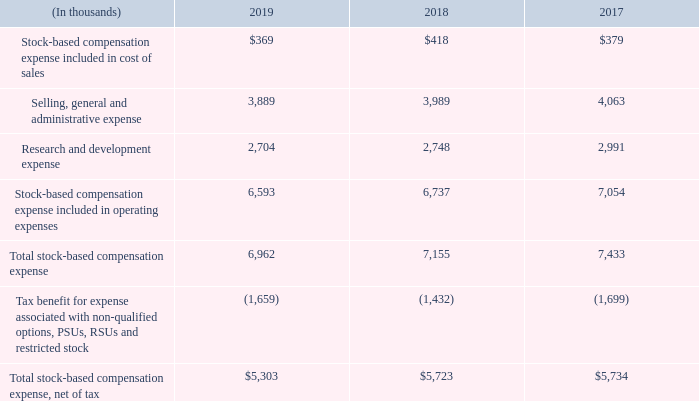Note 4 – Stock-Based Compensation
Stock Incentive Program Descriptions
In January 2006, the Board of Directors adopted the ADTRAN, Inc. 2006 Employee Stock Incentive Plan (the “2006 Plan”), which authorized 13.0 million shares of common stock for issuance to certain employees and officers through incentive stock options and non-qualified stock options, stock appreciation rights, RSUs and restricted stock. The 2006 Plan was adopted by stockholder approval at our annual meeting of stockholders held in May 2006. Options granted under the 2006 Plan typically become exercisable beginning after one year of continued employment, normally pursuant to a four-year vesting schedule beginning on the first anniversary of the grant date and had a ten-year contractual term. The 2006 Plan was replaced in May 2015 by the ADTRAN, Inc. 2015 Employee Stock Incentive Plan (the “2015 Plan”). Expiration dates of options outstanding as of December 31, 2019 under the 2006 Plan range from 2020 to 2024.
In January 2015, the Board of Directors adopted the 2015 Plan, which authorized 7.7 million shares of common stock for issuance to certain employees and officers through incentive stock options and non-qualified stock options, stock appreciation rights, PSUs, RSUs and restricted stock. The 2015 Plan was adopted by stockholder approval at our annual meeting of stockholders held in May 2015. PSUs, RSUs and restricted stock granted under the 2015 Plan reduce the shares authorized for issuance under the 2015 Plan by 2.5 shares of common stock for each share underlying the award. Options granted under the 2015 Plan typically become exercisable beginning after one year of continued employment, normally pursuant to a four-year vesting schedule beginning on the first anniversary of the grant date and have a ten-year contractual term. Expiration dates of options outstanding as of December 31, 2019 under the 2015 Plan range from 2025 to 2026.
Our stockholders approved the 2010 Directors Stock Plan (the “2010 Directors Plan”) in May 2010, under which 0.5 million shares of common stock have been reserved for issuance. This plan replaced the 2005 Directors Stock Option Plan. Under the 2010 Directors Plan, the Company may issue stock options, restricted stock and RSUs to our non-employee directors. Stock awards issued under the 2010 Directors Plan become vested in full on the first anniversary of the grant date. Options issued under the 2010 Directors Plan had a ten-year contractual term. All remaining options under the 2010 Directors Plan expired in 2019.
The following table summarizes stock-based compensation expense related to stock options, PSUs, RSUs and restricted stock for the years ended December 31, 2019, 2018 and 2017, which was recognized as follows:
Which year did all the remaining options under the 2010 Directors Plan expire? 2019. What did the 2015 Plan authorize? 7.7 million shares of common stock for issuance to certain employees and officers through incentive stock options and non-qualified stock options, stock appreciation rights, psus, rsus and restricted stock. What was the research and development expense in 2019?
Answer scale should be: thousand. 2,704. What was the change in research and development expense between 2018 and 2019?
Answer scale should be: thousand. 2,704-2,748
Answer: -44. What was the change in total stock-based compensation expense between 2018 and 2019?
Answer scale should be: thousand. 6,962-7,155
Answer: -193. What was the percentage change in total stock-based compensation expense, net of tax between 2017 and 2018?
Answer scale should be: percent. ($5,723-$5,734)/$5,734
Answer: -0.19. 